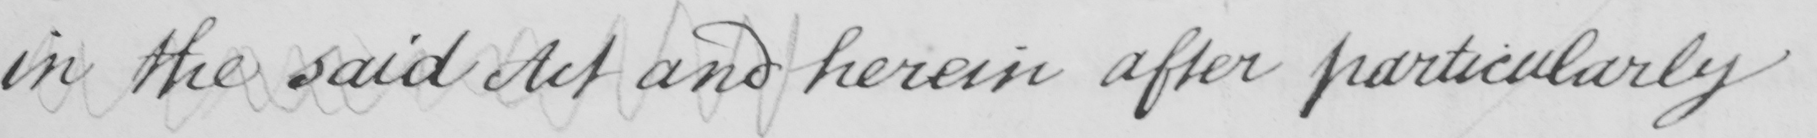Please transcribe the handwritten text in this image. in the said Act and herein after particularly 